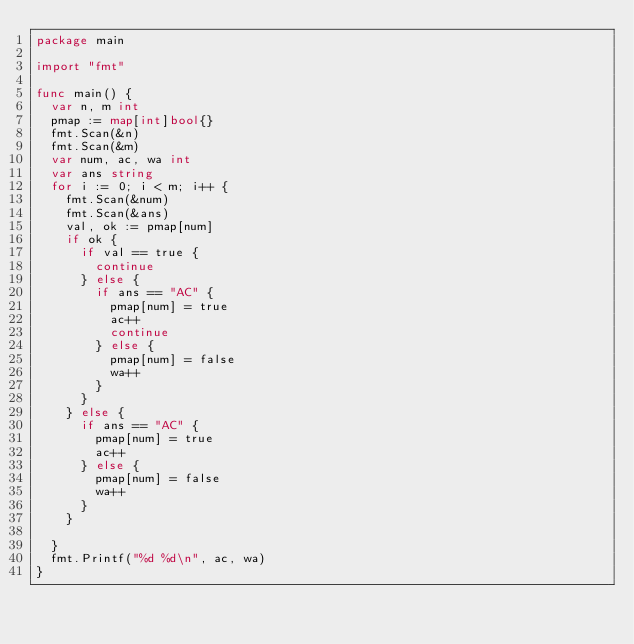Convert code to text. <code><loc_0><loc_0><loc_500><loc_500><_Go_>package main

import "fmt"

func main() {
	var n, m int
	pmap := map[int]bool{}
	fmt.Scan(&n)
	fmt.Scan(&m)
	var num, ac, wa int
	var ans string
	for i := 0; i < m; i++ {
		fmt.Scan(&num)
		fmt.Scan(&ans)
		val, ok := pmap[num]
		if ok {
			if val == true {
				continue
			} else {
				if ans == "AC" {
					pmap[num] = true
					ac++
					continue
				} else {
					pmap[num] = false
					wa++
				}
			}
		} else {
			if ans == "AC" {
				pmap[num] = true
				ac++
			} else {
				pmap[num] = false
				wa++
			}
		}

	}
	fmt.Printf("%d %d\n", ac, wa)
}
</code> 